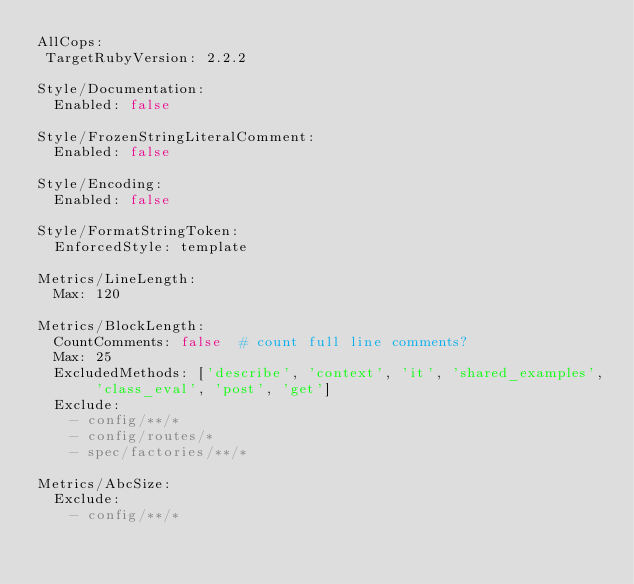Convert code to text. <code><loc_0><loc_0><loc_500><loc_500><_YAML_>AllCops:
 TargetRubyVersion: 2.2.2

Style/Documentation:
  Enabled: false

Style/FrozenStringLiteralComment:
  Enabled: false

Style/Encoding:
  Enabled: false

Style/FormatStringToken:
  EnforcedStyle: template

Metrics/LineLength:
  Max: 120

Metrics/BlockLength:
  CountComments: false  # count full line comments?
  Max: 25
  ExcludedMethods: ['describe', 'context', 'it', 'shared_examples', 'class_eval', 'post', 'get']
  Exclude:
    - config/**/*
    - config/routes/*
    - spec/factories/**/*

Metrics/AbcSize:
  Exclude:
    - config/**/*
</code> 